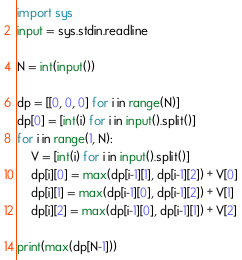Convert code to text. <code><loc_0><loc_0><loc_500><loc_500><_Python_>import sys
input = sys.stdin.readline

N = int(input())

dp = [[0, 0, 0] for i in range(N)]
dp[0] = [int(i) for i in input().split()]
for i in range(1, N):
    V = [int(i) for i in input().split()]
    dp[i][0] = max(dp[i-1][1], dp[i-1][2]) + V[0]
    dp[i][1] = max(dp[i-1][0], dp[i-1][2]) + V[1]
    dp[i][2] = max(dp[i-1][0], dp[i-1][1]) + V[2]

print(max(dp[N-1]))</code> 